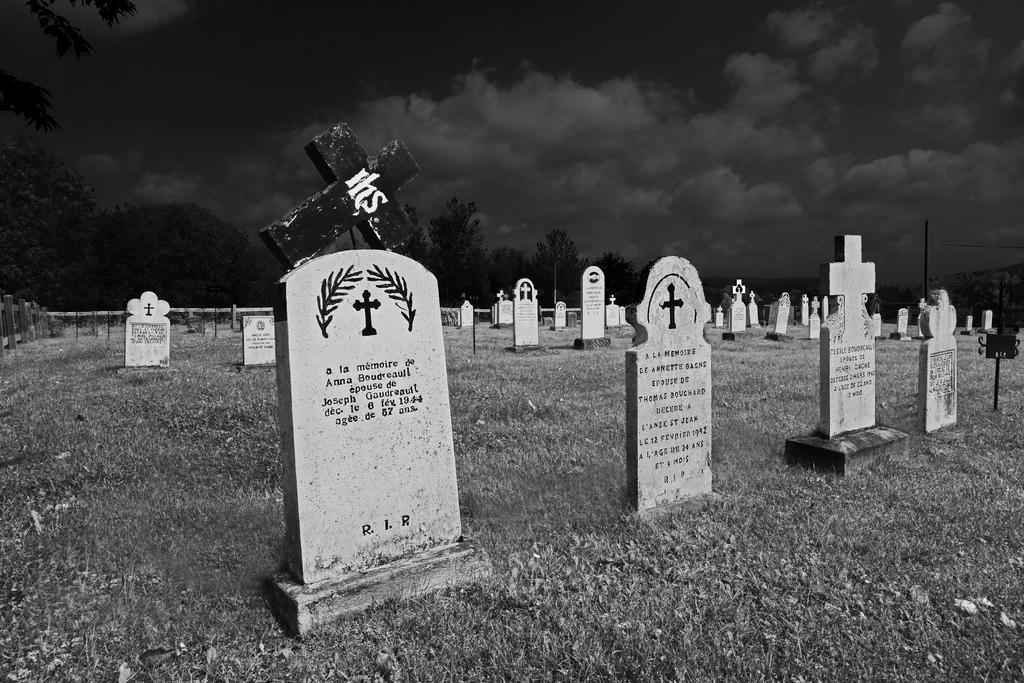What is the main setting of the image? There is a graveyard in the image. What type of natural elements can be seen in the image? There are trees in the image. What is visible in the background of the image? The sky is visible in the image. What type of steam can be seen coming from the graveyard in the image? There is no steam present in the image; it features a graveyard, trees, and the sky. 